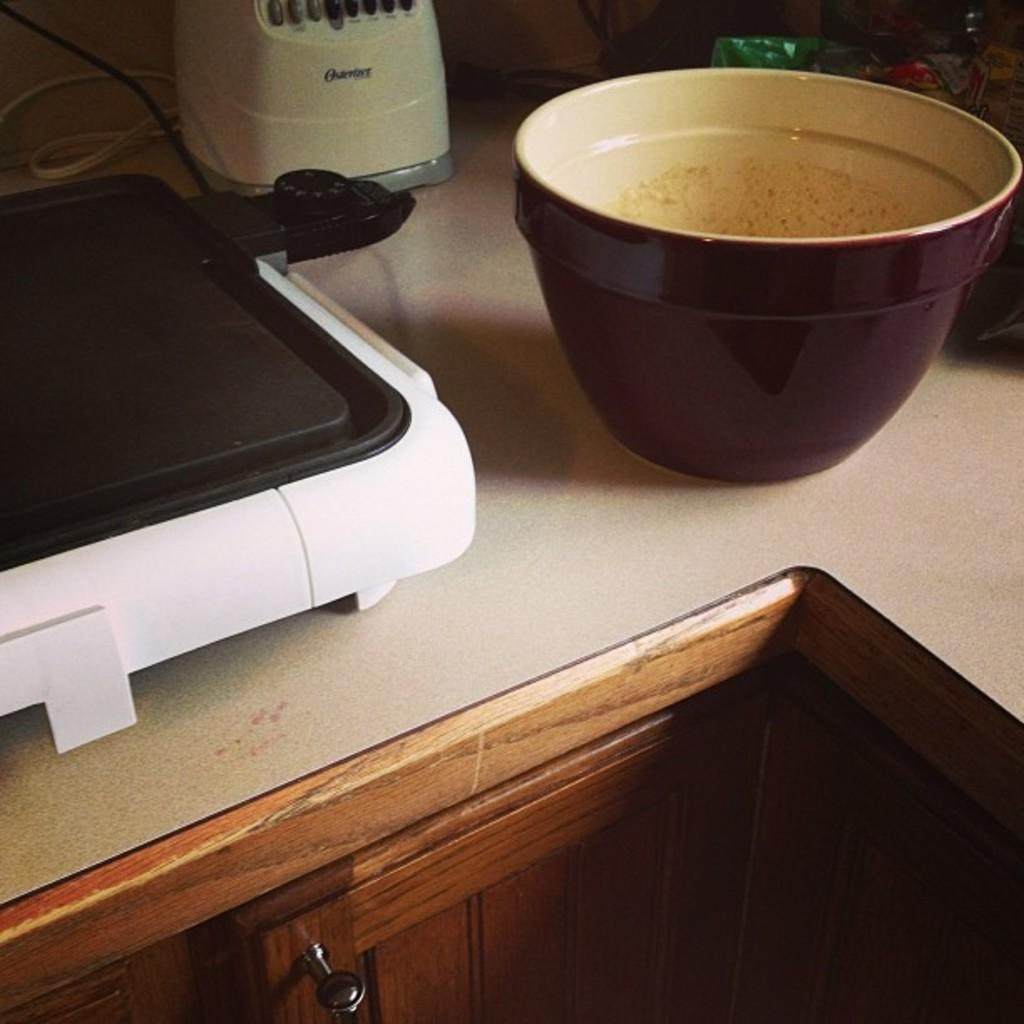<image>
Relay a brief, clear account of the picture shown. an appliance that has osterlove written on it 